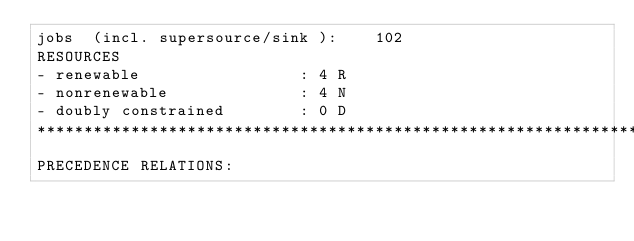<code> <loc_0><loc_0><loc_500><loc_500><_ObjectiveC_>jobs  (incl. supersource/sink ):	102
RESOURCES
- renewable                 : 4 R
- nonrenewable              : 4 N
- doubly constrained        : 0 D
************************************************************************
PRECEDENCE RELATIONS:</code> 